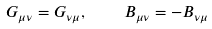<formula> <loc_0><loc_0><loc_500><loc_500>G _ { \mu \nu } = G _ { \nu \mu } , \quad B _ { \mu \nu } = - B _ { \nu \mu }</formula> 